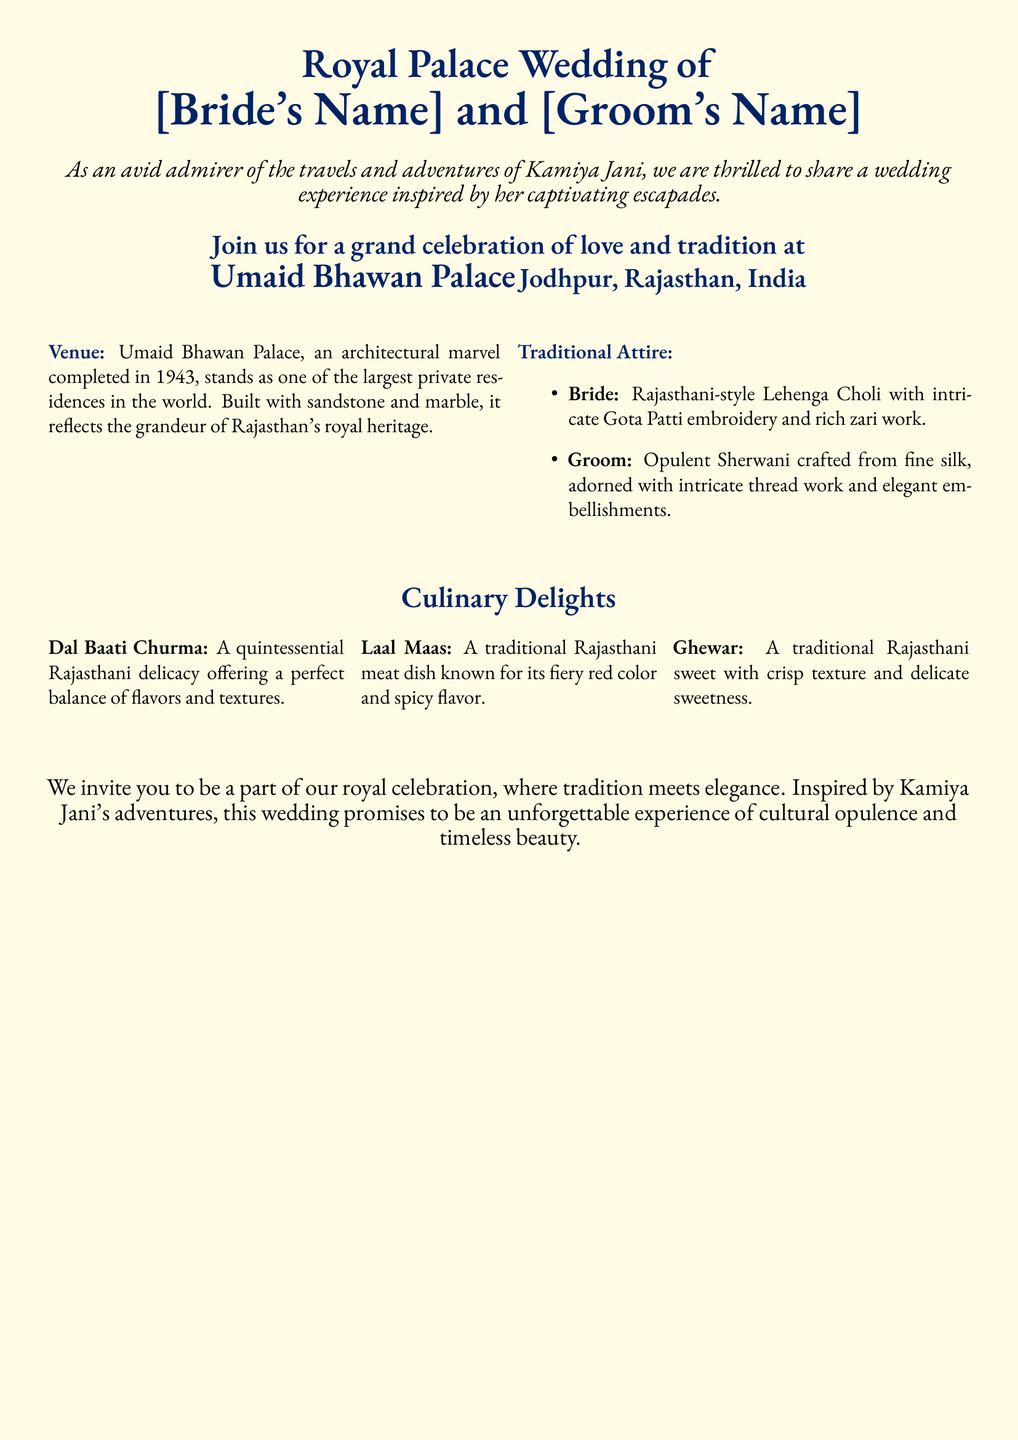What is the venue for the wedding? The venue is mentioned as Umaid Bhawan Palace in Jodhpur, Rajasthan, India.
Answer: Umaid Bhawan Palace What is the traditional attire for the bride? The document specifies that the bride will wear a Rajasthani-style Lehenga Choli with intricate Gota Patti embroidery and rich zari work.
Answer: Rajasthani-style Lehenga Choli What dish is known for its spicy flavor? Laal Maas is highlighted in the document as a traditional Rajasthani meat dish known for its fiery red color and spicy flavor.
Answer: Laal Maas In which year was Umaid Bhawan Palace completed? The document states that Umaid Bhawan Palace was completed in 1943.
Answer: 1943 What type of cuisine is featured in the wedding? The document lists various Rajasthani delicacies, indicating that the cuisine is inspired by Rajasthani culinary traditions.
Answer: Rajasthani Who is the wedding experience inspired by? The invitation mentions that the wedding experience is inspired by Kamiya Jani's travels and adventures.
Answer: Kamiya Jani What type of cuisine is Ghewar? The document describes Ghewar as a traditional Rajasthani sweet with crisp texture and delicate sweetness.
Answer: Sweet What kind of embroidery is on the bride's attire? The bride’s attire features intricate Gota Patti embroidery and rich zari work.
Answer: Gota Patti embroidery 